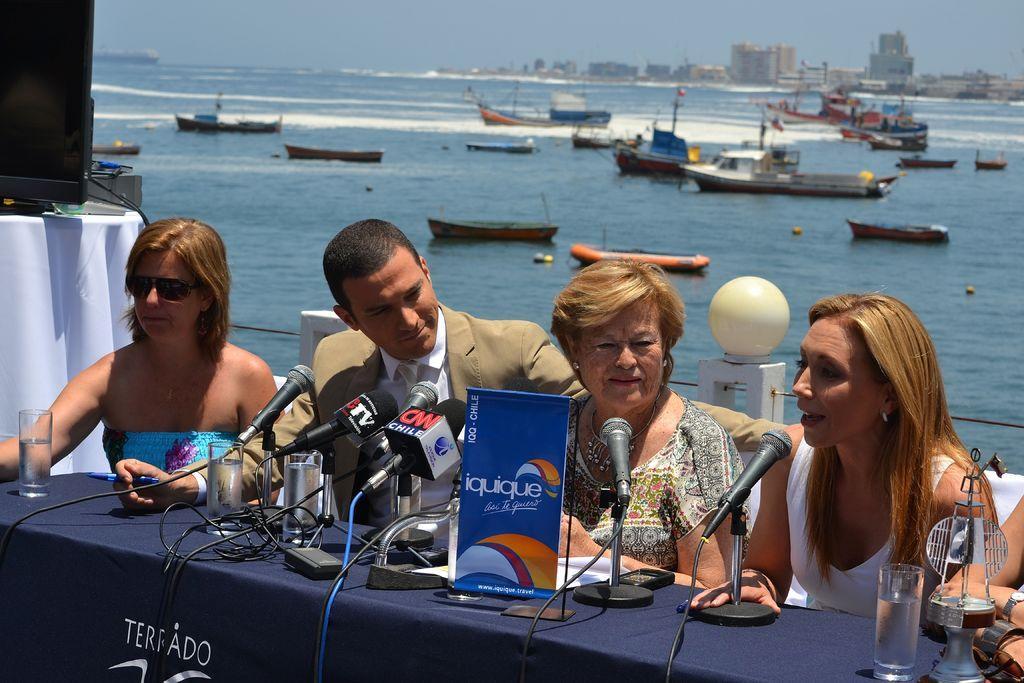Describe this image in one or two sentences. Here we can see a man and three women sitting on the chair at the table. On the table we can see microphones,glasses,cables,tag and some other objects. In the background we can see a TV on a table and we can also see boats on the water and also buildings and sky. 